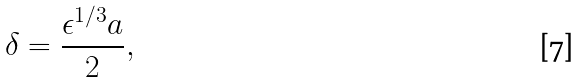<formula> <loc_0><loc_0><loc_500><loc_500>\delta = \frac { \epsilon ^ { 1 / 3 } a } { 2 } ,</formula> 